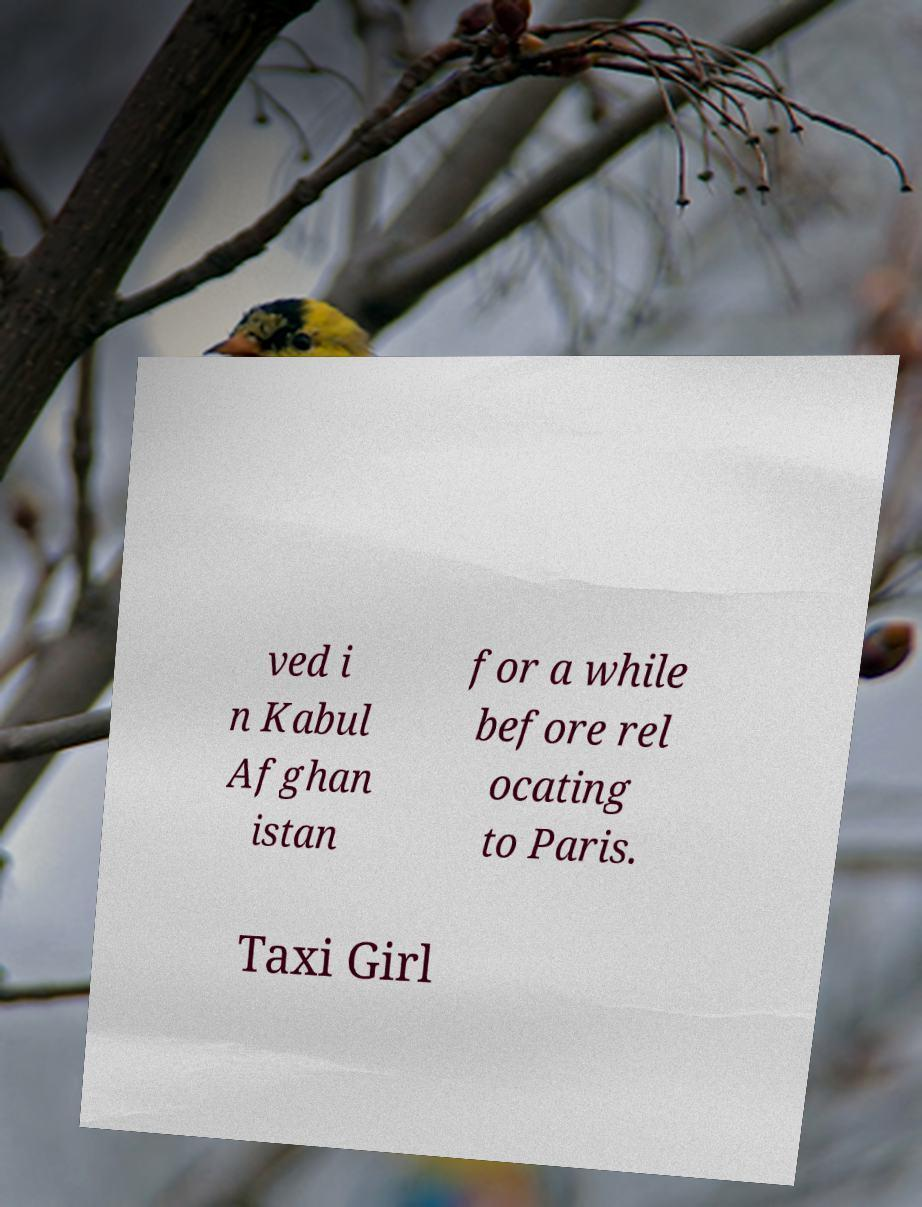Can you accurately transcribe the text from the provided image for me? ved i n Kabul Afghan istan for a while before rel ocating to Paris. Taxi Girl 